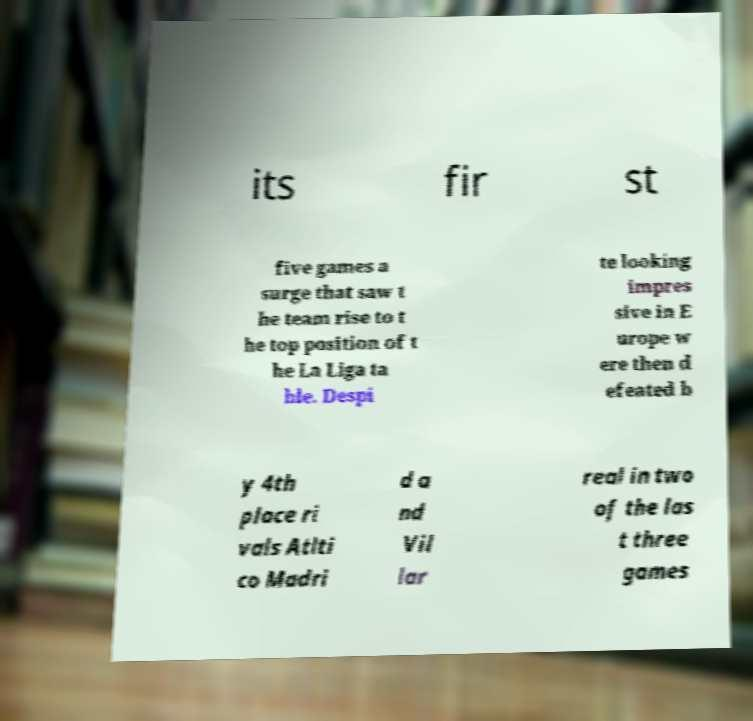There's text embedded in this image that I need extracted. Can you transcribe it verbatim? its fir st five games a surge that saw t he team rise to t he top position of t he La Liga ta ble. Despi te looking impres sive in E urope w ere then d efeated b y 4th place ri vals Atlti co Madri d a nd Vil lar real in two of the las t three games 